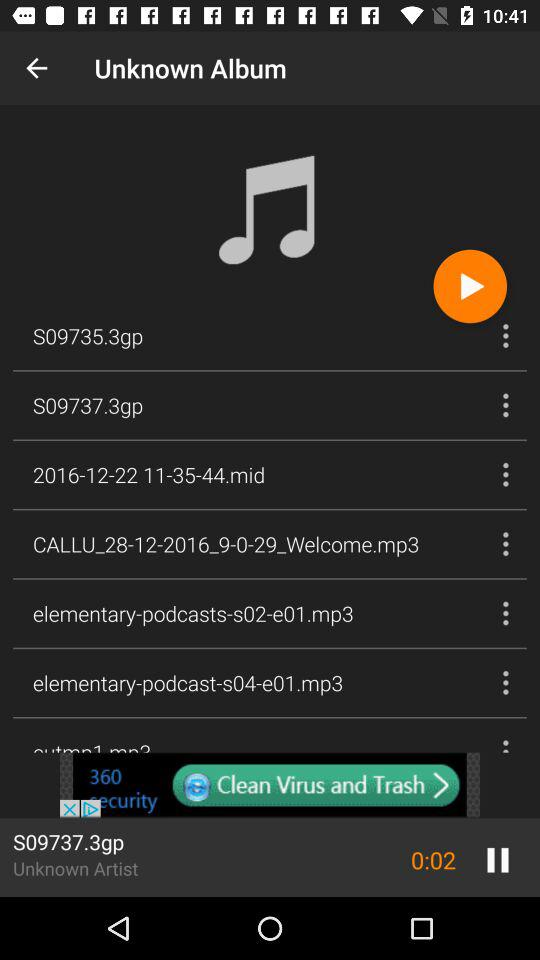What is the name of the artist of the currently playing song?
Answer the question using a single word or phrase. Unknown Artist 